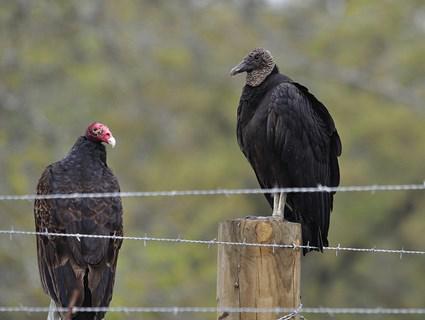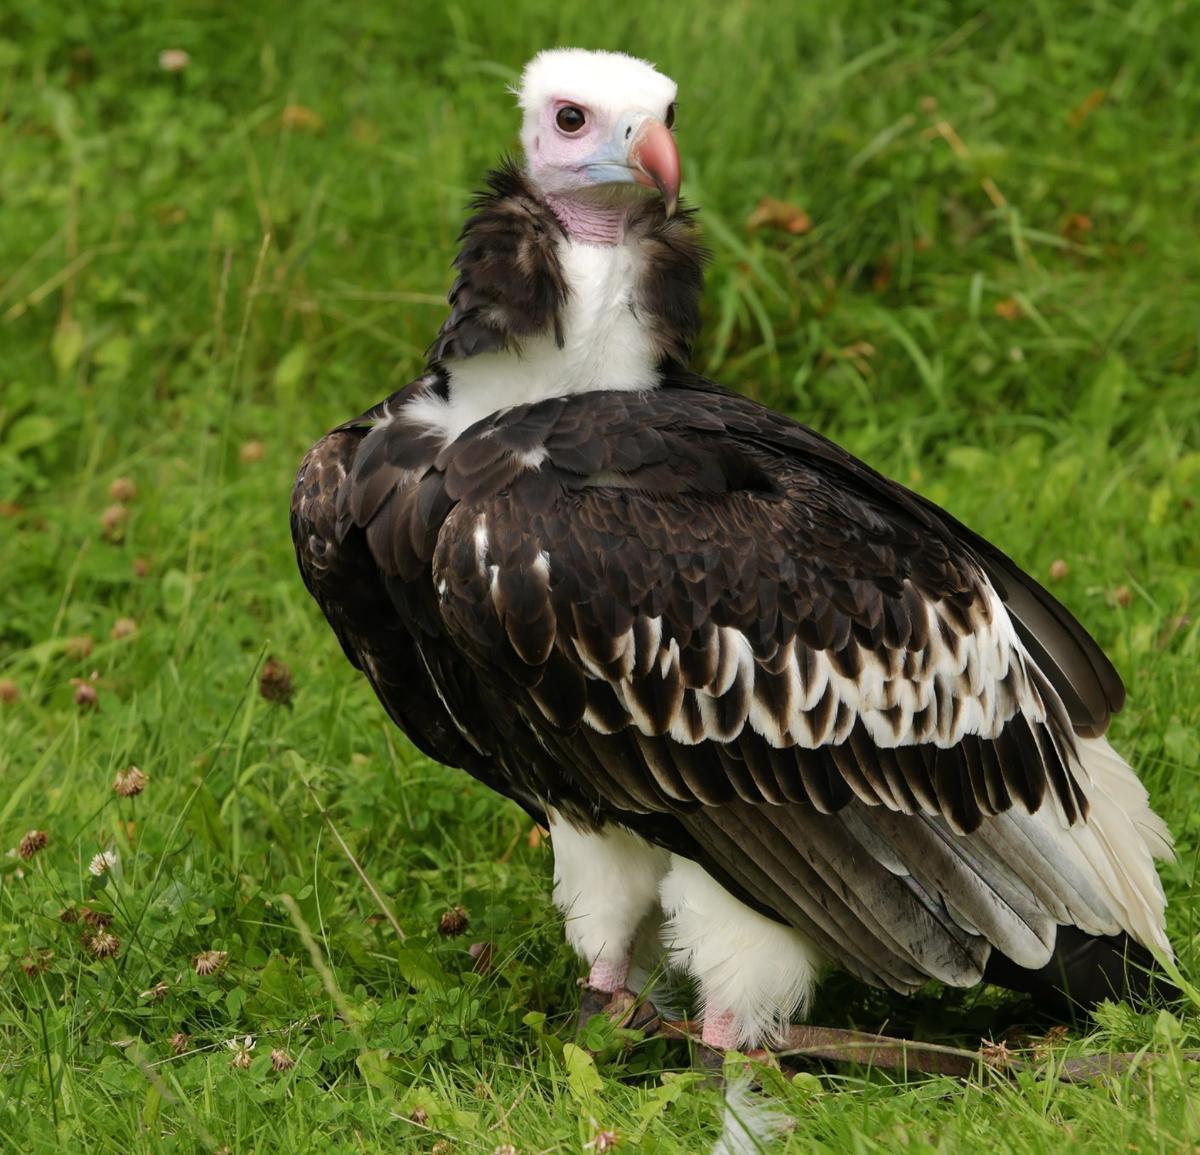The first image is the image on the left, the second image is the image on the right. Assess this claim about the two images: "There is no more than one bird on the left image.". Correct or not? Answer yes or no. No. 